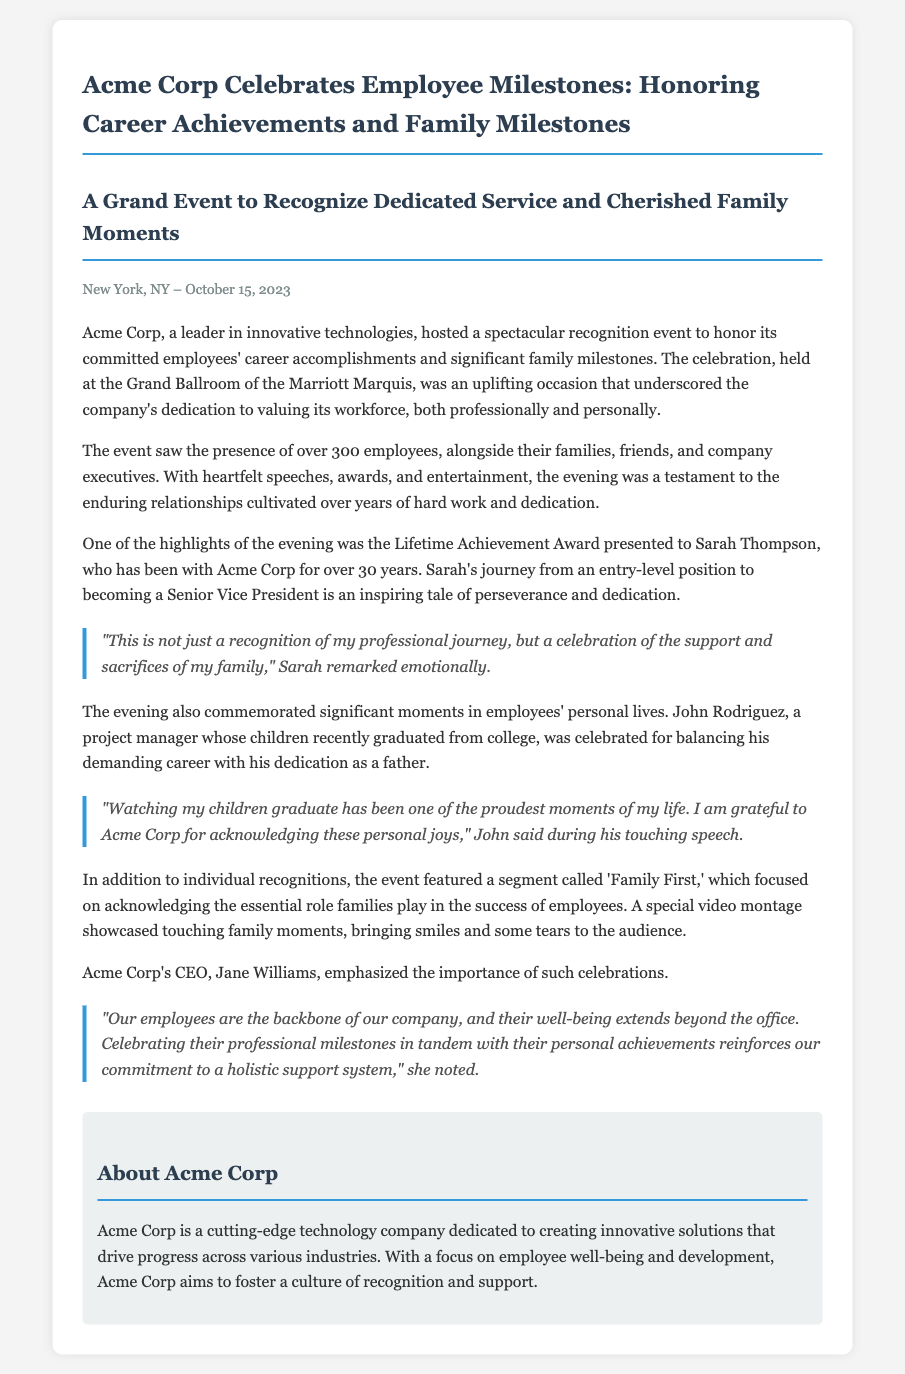What was the date of the event? The date of the event is mentioned as when it took place, which is October 15, 2023.
Answer: October 15, 2023 Who received the Lifetime Achievement Award? The award was presented to acknowledge outstanding long-term contributions, specifically to Sarah Thompson.
Answer: Sarah Thompson How many employees attended the event? The document states that over 300 employees were present at the celebration.
Answer: over 300 What is one key focus of the 'Family First' segment? This segment emphasizes acknowledging the essential role families play in the success of employees.
Answer: Acknowledging families What did CEO Jane Williams say was important? Jane Williams emphasized the importance of celebrating professional milestones in tandem with personal achievements for employee well-being.
Answer: Employee well-being What is Acme Corp primarily dedicated to? The document specifies that Acme Corp is dedicated to creating innovative solutions in technology.
Answer: Innovative solutions 